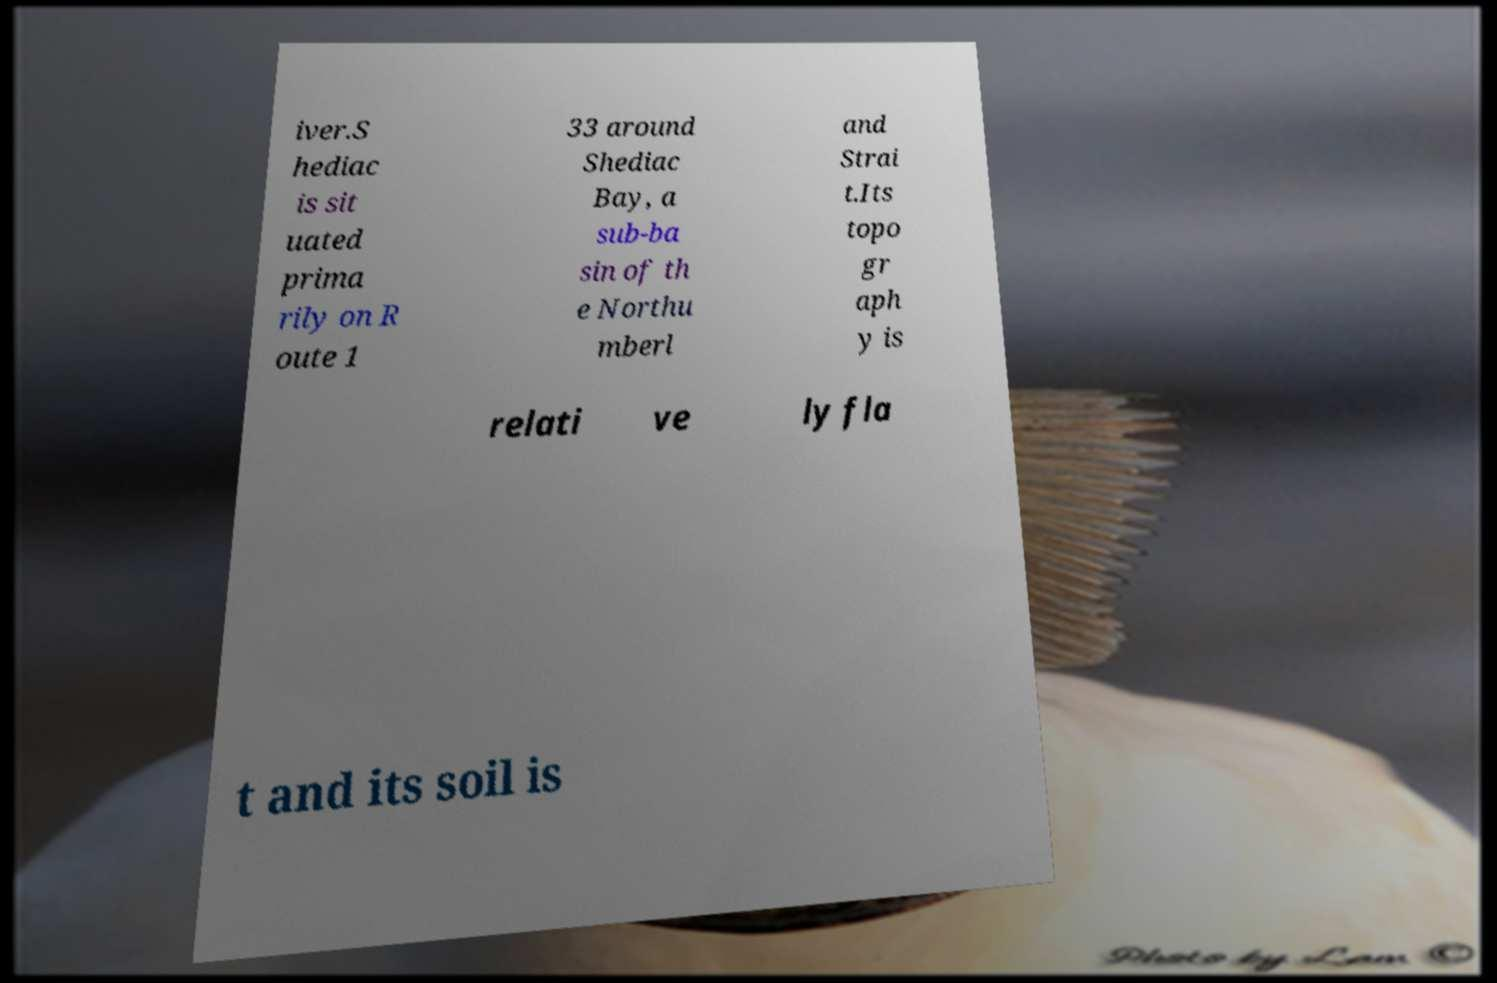What messages or text are displayed in this image? I need them in a readable, typed format. iver.S hediac is sit uated prima rily on R oute 1 33 around Shediac Bay, a sub-ba sin of th e Northu mberl and Strai t.Its topo gr aph y is relati ve ly fla t and its soil is 